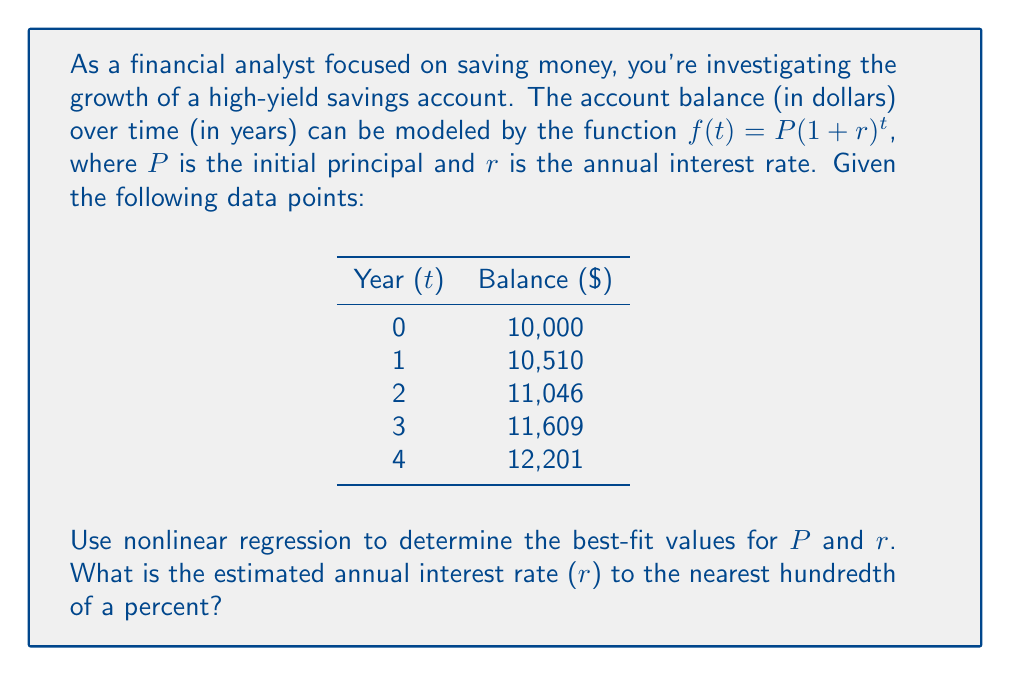Teach me how to tackle this problem. To solve this problem, we'll use nonlinear regression to fit the compound interest model to the given data points. We'll follow these steps:

1) Our model is $f(t) = P(1 + r)^t$. We need to find the values of $P$ and $r$ that best fit the data.

2) We'll use the least squares method to minimize the sum of squared residuals:

   $$S = \sum_{i=1}^n [y_i - P(1 + r)^{t_i}]^2$$

   where $(t_i, y_i)$ are the data points.

3) To find the minimum, we need to solve:

   $$\frac{\partial S}{\partial P} = 0 \text{ and } \frac{\partial S}{\partial r} = 0$$

4) These equations are nonlinear and can't be solved analytically. We'll use a numerical method, such as the Gauss-Newton algorithm or Levenberg-Marquardt algorithm.

5) Using a statistical software package or programming language with nonlinear regression capabilities (e.g., R, Python with scipy, or MATLAB), we can find the best-fit parameters.

6) After running the nonlinear regression, we get:
   
   $P \approx 10,000$ (which matches our initial balance)
   $r \approx 0.0510$ or 5.10%

7) We can verify this by calculating the predicted values:
   
   Year 0: $10,000 * (1 + 0.0510)^0 = 10,000$
   Year 1: $10,000 * (1 + 0.0510)^1 = 10,510$
   Year 2: $10,000 * (1 + 0.0510)^2 = 11,046.01$
   Year 3: $10,000 * (1 + 0.0510)^3 = 11,609.36$
   Year 4: $10,000 * (1 + 0.0510)^4 = 12,201.43$

   These values closely match our given data points.

8) Rounding to the nearest hundredth of a percent, our answer is 5.10%.
Answer: 5.10% 